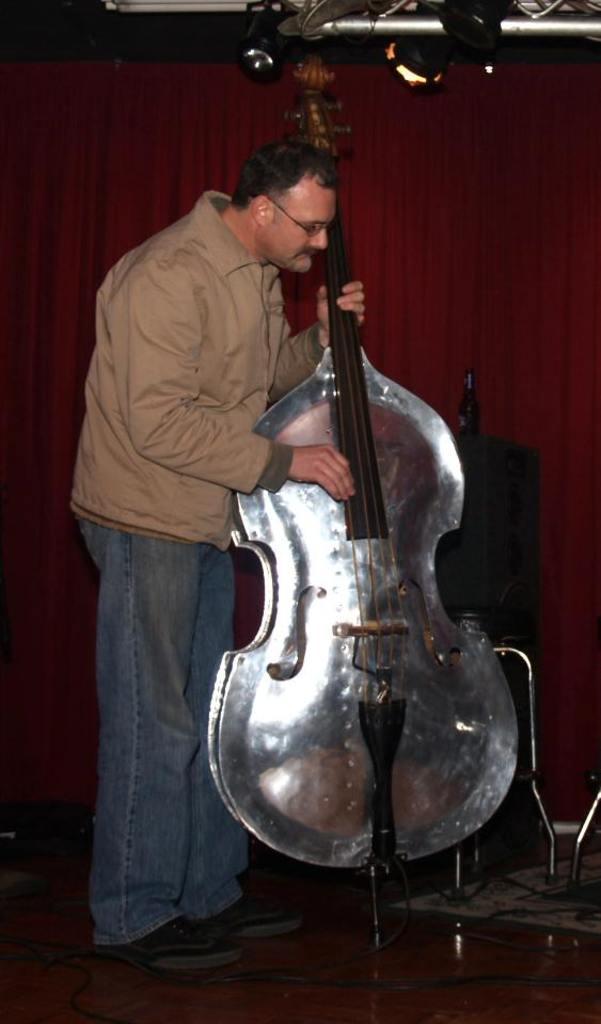Could you give a brief overview of what you see in this image? In this image we can see a man standing on the floor and holding the bass in his hands. In the background we can see curtain and cables. 